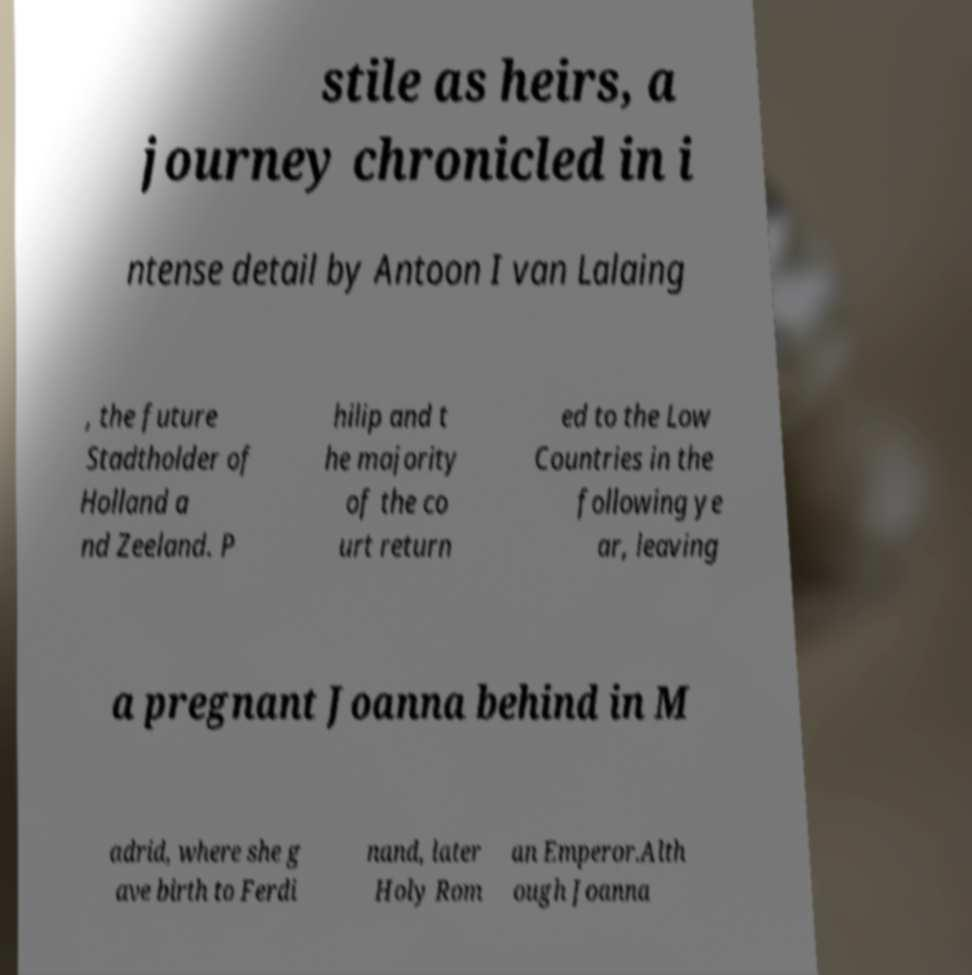What messages or text are displayed in this image? I need them in a readable, typed format. stile as heirs, a journey chronicled in i ntense detail by Antoon I van Lalaing , the future Stadtholder of Holland a nd Zeeland. P hilip and t he majority of the co urt return ed to the Low Countries in the following ye ar, leaving a pregnant Joanna behind in M adrid, where she g ave birth to Ferdi nand, later Holy Rom an Emperor.Alth ough Joanna 